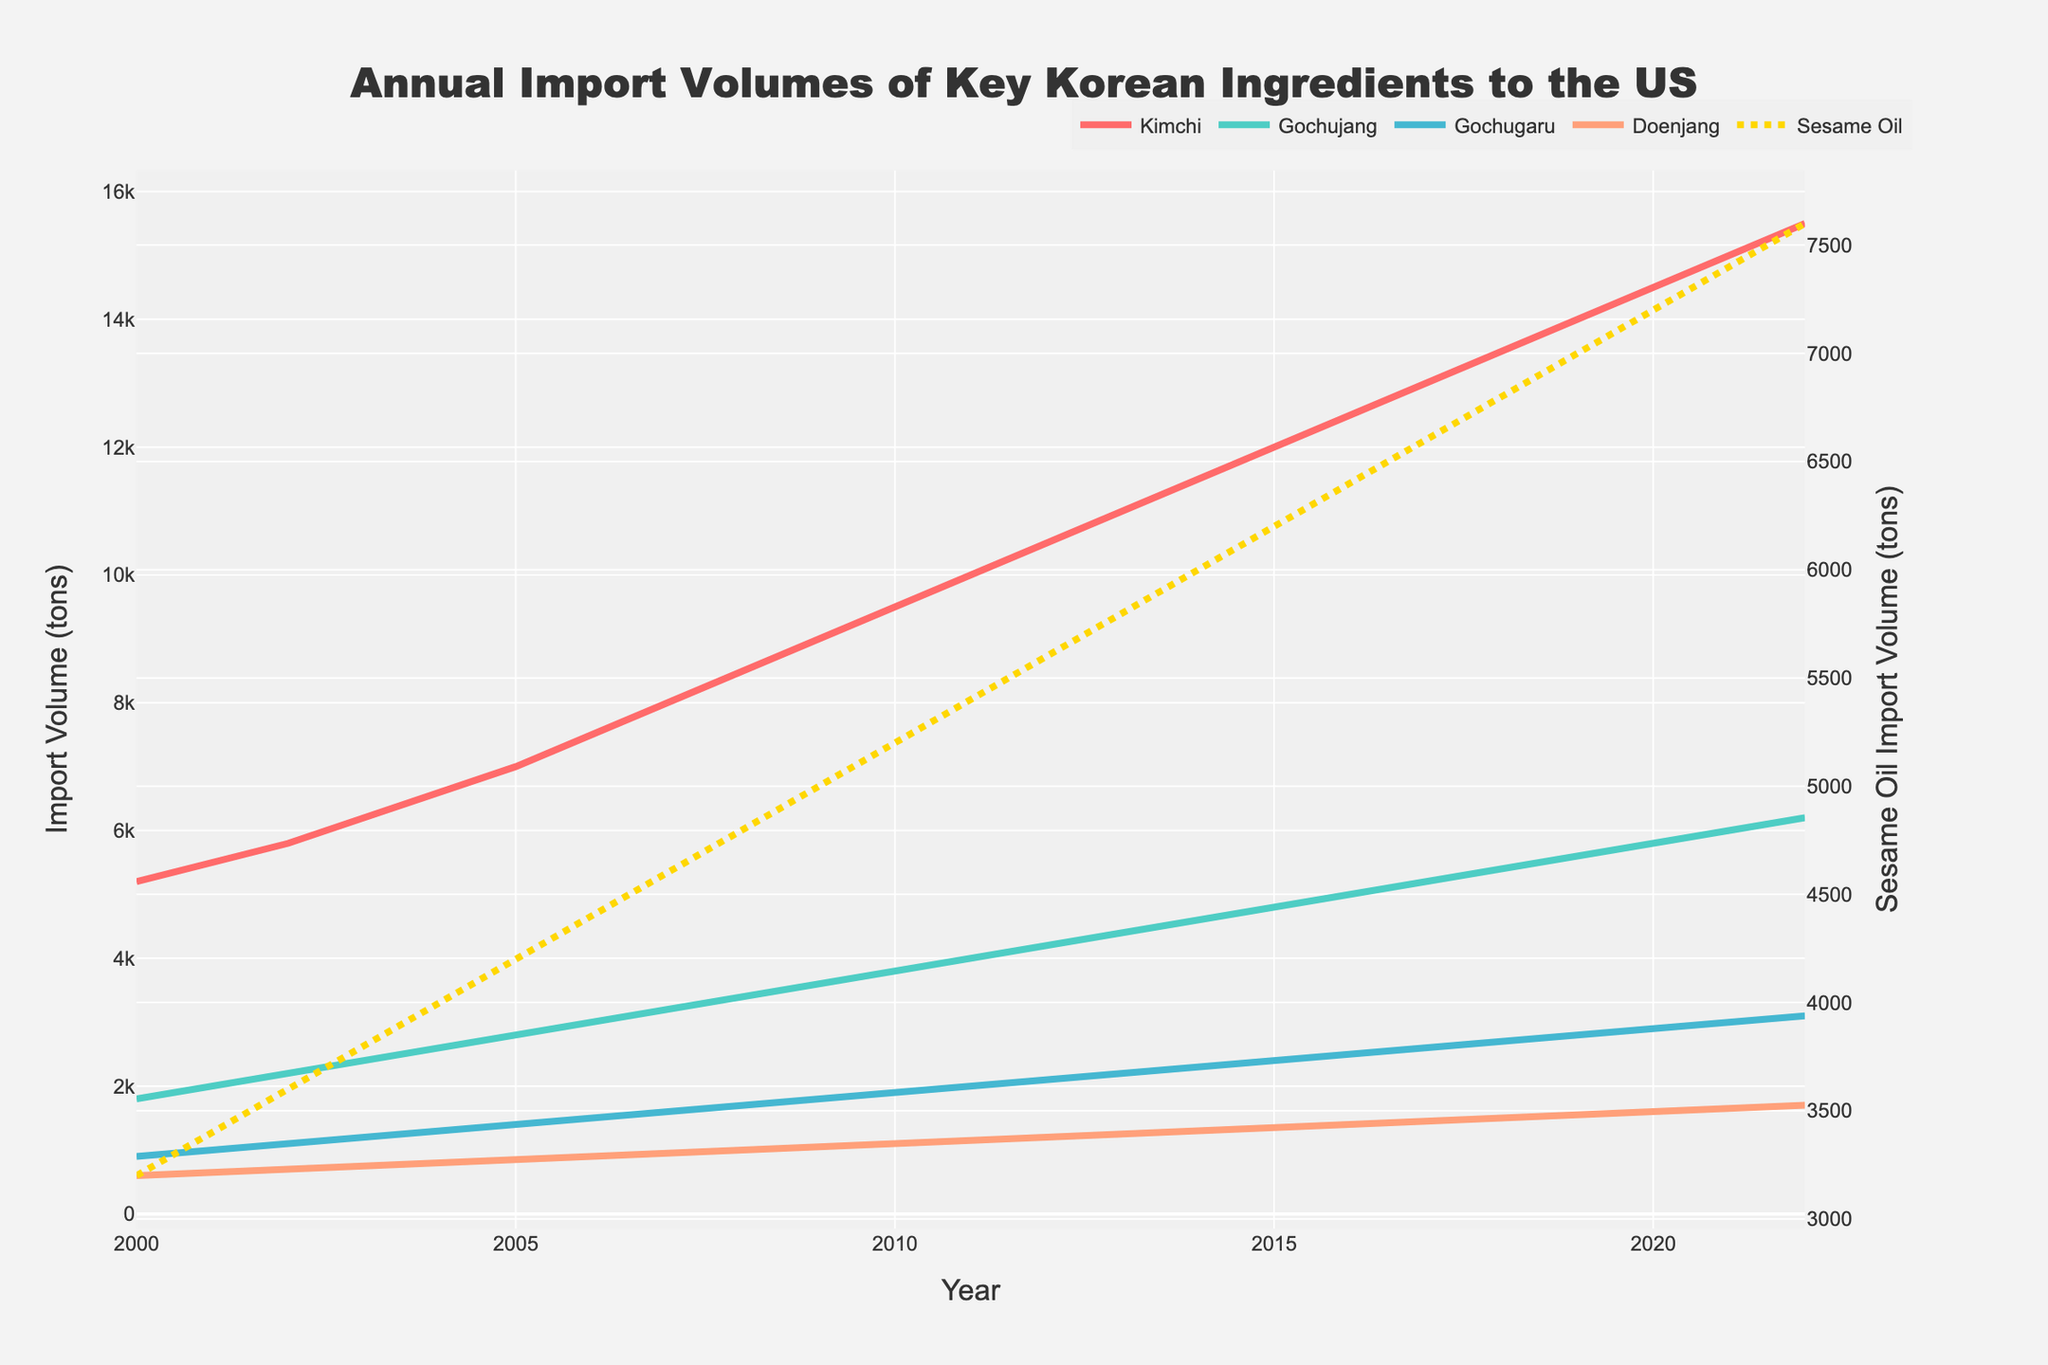What is the trend in the import volume of Kimchi from 2000 to 2022? Observe the red line representing Kimchi on the plot. It demonstrates a steadily increasing trend from 5200 tons in 2000 to 15500 tons in 2022, indicating growing demand or supply for Kimchi over these years.
Answer: Increasing Which ingredient had the highest import volume in 2022? By comparing the endpoints of each ingredient's line, you can see that Kimchi, represented by the red line, reaches the highest point in 2022 at 15500 tons, surpassing all other ingredients.
Answer: Kimchi How does the import volume of Gochujang in 2010 compare to its volume in 2020? Look at the endpoints for Gochujang (green line) for the years 2010 and 2020. The import volume increases from 3800 tons in 2010 to 5800 tons in 2020.
Answer: It increased What are the average import volumes of Doenjang from 2000 to 2022? Sum all the annual volumes of Doenjang and divide by the total number of years (23). Sum: 600+650+700+750+800+850+900+950+1000+1050+1100+1150+1200+1250+1300+1350+1400+1450+1500+1550+1600+1650+1700 = 28700. Average = 28700/23 ≈ 1247.83
Answer: 1247.83 tons Did Gochugaru's import volume ever exceed that of Sesame Oil? Observe the blue line (Gochugaru) and the dotted yellow line (Sesame Oil) across the whole period. The yellow line is always above the blue line, indicating Sesame Oil imports were consistently higher.
Answer: No Compare the relative rates of increase in import volumes of Kimchi and Gochujang between 2005 and 2015. For Kimchi, from 7000 tons in 2005 to 12000 tons in 2015, the increase is 12000 - 7000 = 5000 tons. For Gochujang, from 2800 tons in 2005 to 4800 tons in 2015, the increase is 4800 - 2800 = 2000 tons. Therefore, Kimchi experienced a larger absolute increase while Gochujang had a lower increase rate.
Answer: Kimchi: 5000 tons, Gochujang: 2000 tons What was the import volume of Sesame Oil in 2013, and how does it compare to the total import volume of Doenjang and Gochugaru in the same year? From the graph, the import volume of Sesame Oil in 2013 is 5800 tons. The combined import volume of Doenjang (1250 tons) and Gochugaru (2200 tons) in 2013 is 1250 + 2200 = 3450 tons.
Answer: Sesame Oil: 5800 tons, Combined Doenjang and Gochugaru: 3450 tons What was the highest annual import volume for each Korean ingredient, and which year did it occur? Obtaining max values from graph endpoint and line peaks, we have: Kimchi (15500 tons in 2022), Gochujang (6200 tons in 2022), Gochugaru (3100 tons in 2022), Doenjang (1700 tons in 2022), and Sesame Oil (7600 tons in 2022).
Answer: Kimchi: 15500 tons (2022), Gochujang: 6200 tons (2022), Gochugaru: 3100 tons (2022), Doenjang: 1700 tons (2022), Sesame Oil: 7600 tons (2022) How did the import volume of Kimchi in 2022 compare to the combined import volumes of Gochujang and Gochugaru in 2020? Kimchi in 2022: 15500 tons. Combined Gochujang (5800 tons) and Gochugaru (2900 tons) in 2020: 5800 + 2900 = 8700 tons. Kimchi import volume in 2022 is significantly higher.
Answer: Kimchi in 2022: 15500 tons, Combined Gochujang and Gochugaru in 2020: 8700 tons 